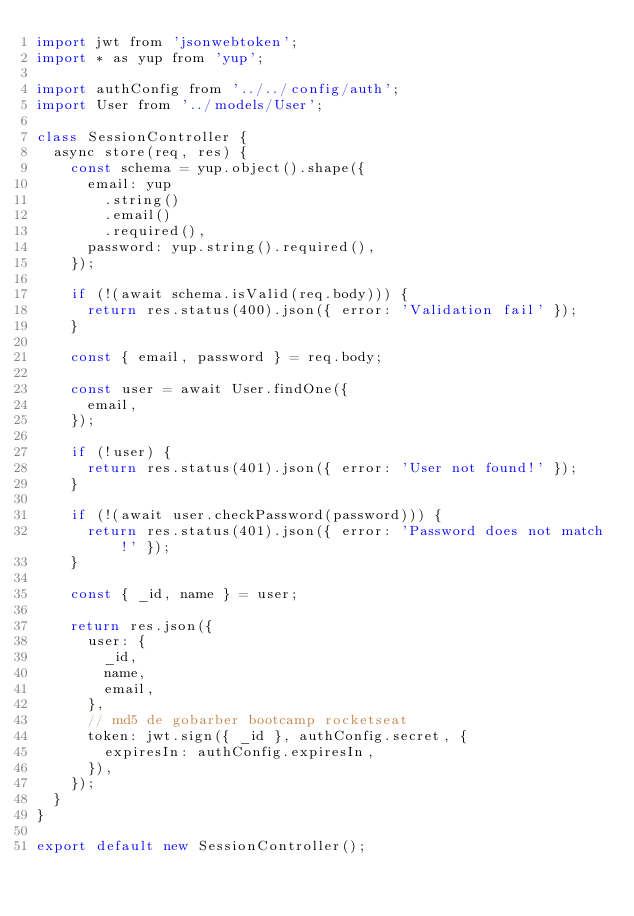Convert code to text. <code><loc_0><loc_0><loc_500><loc_500><_JavaScript_>import jwt from 'jsonwebtoken';
import * as yup from 'yup';

import authConfig from '../../config/auth';
import User from '../models/User';

class SessionController {
  async store(req, res) {
    const schema = yup.object().shape({
      email: yup
        .string()
        .email()
        .required(),
      password: yup.string().required(),
    });

    if (!(await schema.isValid(req.body))) {
      return res.status(400).json({ error: 'Validation fail' });
    }

    const { email, password } = req.body;

    const user = await User.findOne({
      email,
    });

    if (!user) {
      return res.status(401).json({ error: 'User not found!' });
    }

    if (!(await user.checkPassword(password))) {
      return res.status(401).json({ error: 'Password does not match!' });
    }

    const { _id, name } = user;

    return res.json({
      user: {
        _id,
        name,
        email,
      },
      // md5 de gobarber bootcamp rocketseat
      token: jwt.sign({ _id }, authConfig.secret, {
        expiresIn: authConfig.expiresIn,
      }),
    });
  }
}

export default new SessionController();
</code> 